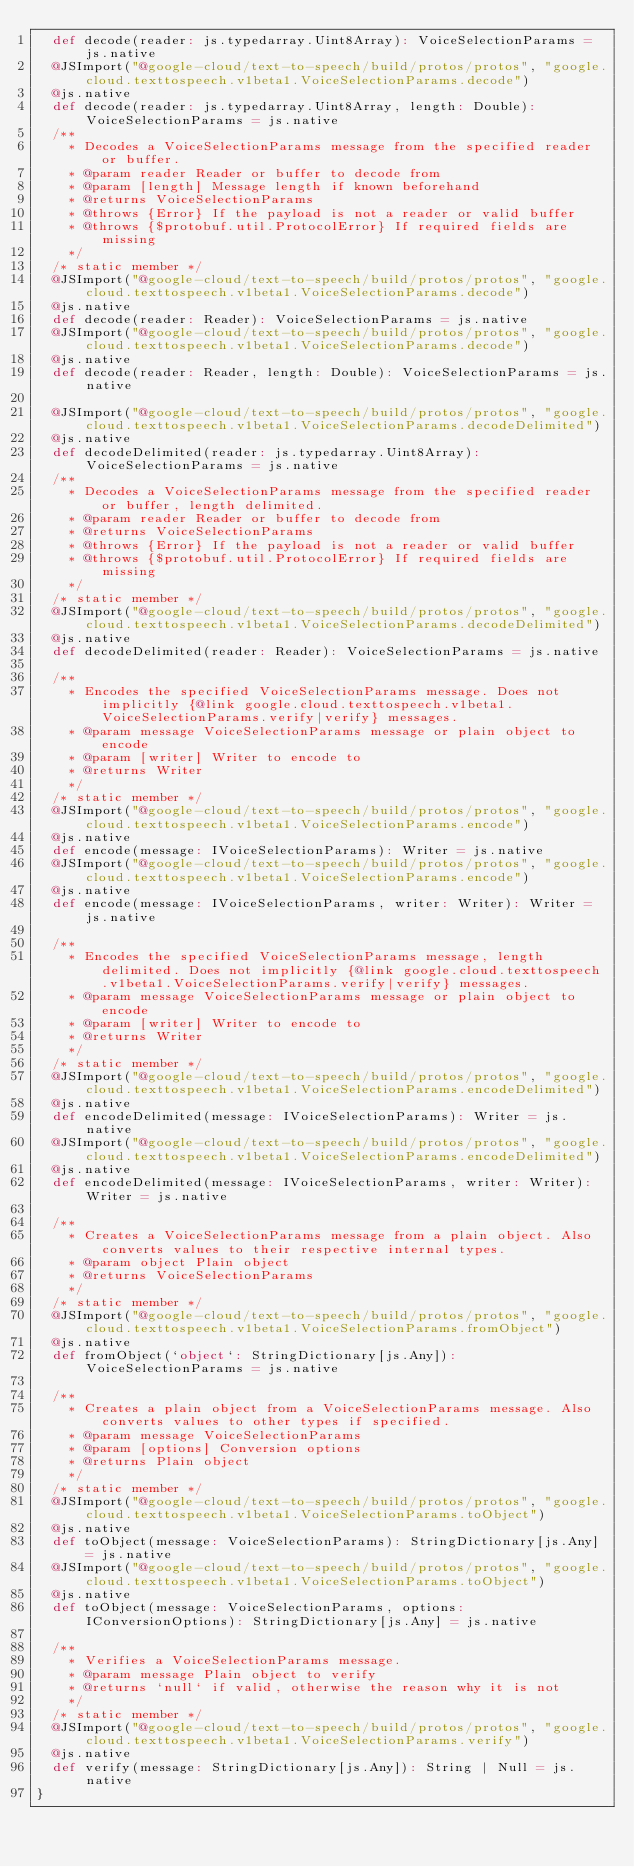<code> <loc_0><loc_0><loc_500><loc_500><_Scala_>  def decode(reader: js.typedarray.Uint8Array): VoiceSelectionParams = js.native
  @JSImport("@google-cloud/text-to-speech/build/protos/protos", "google.cloud.texttospeech.v1beta1.VoiceSelectionParams.decode")
  @js.native
  def decode(reader: js.typedarray.Uint8Array, length: Double): VoiceSelectionParams = js.native
  /**
    * Decodes a VoiceSelectionParams message from the specified reader or buffer.
    * @param reader Reader or buffer to decode from
    * @param [length] Message length if known beforehand
    * @returns VoiceSelectionParams
    * @throws {Error} If the payload is not a reader or valid buffer
    * @throws {$protobuf.util.ProtocolError} If required fields are missing
    */
  /* static member */
  @JSImport("@google-cloud/text-to-speech/build/protos/protos", "google.cloud.texttospeech.v1beta1.VoiceSelectionParams.decode")
  @js.native
  def decode(reader: Reader): VoiceSelectionParams = js.native
  @JSImport("@google-cloud/text-to-speech/build/protos/protos", "google.cloud.texttospeech.v1beta1.VoiceSelectionParams.decode")
  @js.native
  def decode(reader: Reader, length: Double): VoiceSelectionParams = js.native
  
  @JSImport("@google-cloud/text-to-speech/build/protos/protos", "google.cloud.texttospeech.v1beta1.VoiceSelectionParams.decodeDelimited")
  @js.native
  def decodeDelimited(reader: js.typedarray.Uint8Array): VoiceSelectionParams = js.native
  /**
    * Decodes a VoiceSelectionParams message from the specified reader or buffer, length delimited.
    * @param reader Reader or buffer to decode from
    * @returns VoiceSelectionParams
    * @throws {Error} If the payload is not a reader or valid buffer
    * @throws {$protobuf.util.ProtocolError} If required fields are missing
    */
  /* static member */
  @JSImport("@google-cloud/text-to-speech/build/protos/protos", "google.cloud.texttospeech.v1beta1.VoiceSelectionParams.decodeDelimited")
  @js.native
  def decodeDelimited(reader: Reader): VoiceSelectionParams = js.native
  
  /**
    * Encodes the specified VoiceSelectionParams message. Does not implicitly {@link google.cloud.texttospeech.v1beta1.VoiceSelectionParams.verify|verify} messages.
    * @param message VoiceSelectionParams message or plain object to encode
    * @param [writer] Writer to encode to
    * @returns Writer
    */
  /* static member */
  @JSImport("@google-cloud/text-to-speech/build/protos/protos", "google.cloud.texttospeech.v1beta1.VoiceSelectionParams.encode")
  @js.native
  def encode(message: IVoiceSelectionParams): Writer = js.native
  @JSImport("@google-cloud/text-to-speech/build/protos/protos", "google.cloud.texttospeech.v1beta1.VoiceSelectionParams.encode")
  @js.native
  def encode(message: IVoiceSelectionParams, writer: Writer): Writer = js.native
  
  /**
    * Encodes the specified VoiceSelectionParams message, length delimited. Does not implicitly {@link google.cloud.texttospeech.v1beta1.VoiceSelectionParams.verify|verify} messages.
    * @param message VoiceSelectionParams message or plain object to encode
    * @param [writer] Writer to encode to
    * @returns Writer
    */
  /* static member */
  @JSImport("@google-cloud/text-to-speech/build/protos/protos", "google.cloud.texttospeech.v1beta1.VoiceSelectionParams.encodeDelimited")
  @js.native
  def encodeDelimited(message: IVoiceSelectionParams): Writer = js.native
  @JSImport("@google-cloud/text-to-speech/build/protos/protos", "google.cloud.texttospeech.v1beta1.VoiceSelectionParams.encodeDelimited")
  @js.native
  def encodeDelimited(message: IVoiceSelectionParams, writer: Writer): Writer = js.native
  
  /**
    * Creates a VoiceSelectionParams message from a plain object. Also converts values to their respective internal types.
    * @param object Plain object
    * @returns VoiceSelectionParams
    */
  /* static member */
  @JSImport("@google-cloud/text-to-speech/build/protos/protos", "google.cloud.texttospeech.v1beta1.VoiceSelectionParams.fromObject")
  @js.native
  def fromObject(`object`: StringDictionary[js.Any]): VoiceSelectionParams = js.native
  
  /**
    * Creates a plain object from a VoiceSelectionParams message. Also converts values to other types if specified.
    * @param message VoiceSelectionParams
    * @param [options] Conversion options
    * @returns Plain object
    */
  /* static member */
  @JSImport("@google-cloud/text-to-speech/build/protos/protos", "google.cloud.texttospeech.v1beta1.VoiceSelectionParams.toObject")
  @js.native
  def toObject(message: VoiceSelectionParams): StringDictionary[js.Any] = js.native
  @JSImport("@google-cloud/text-to-speech/build/protos/protos", "google.cloud.texttospeech.v1beta1.VoiceSelectionParams.toObject")
  @js.native
  def toObject(message: VoiceSelectionParams, options: IConversionOptions): StringDictionary[js.Any] = js.native
  
  /**
    * Verifies a VoiceSelectionParams message.
    * @param message Plain object to verify
    * @returns `null` if valid, otherwise the reason why it is not
    */
  /* static member */
  @JSImport("@google-cloud/text-to-speech/build/protos/protos", "google.cloud.texttospeech.v1beta1.VoiceSelectionParams.verify")
  @js.native
  def verify(message: StringDictionary[js.Any]): String | Null = js.native
}
</code> 